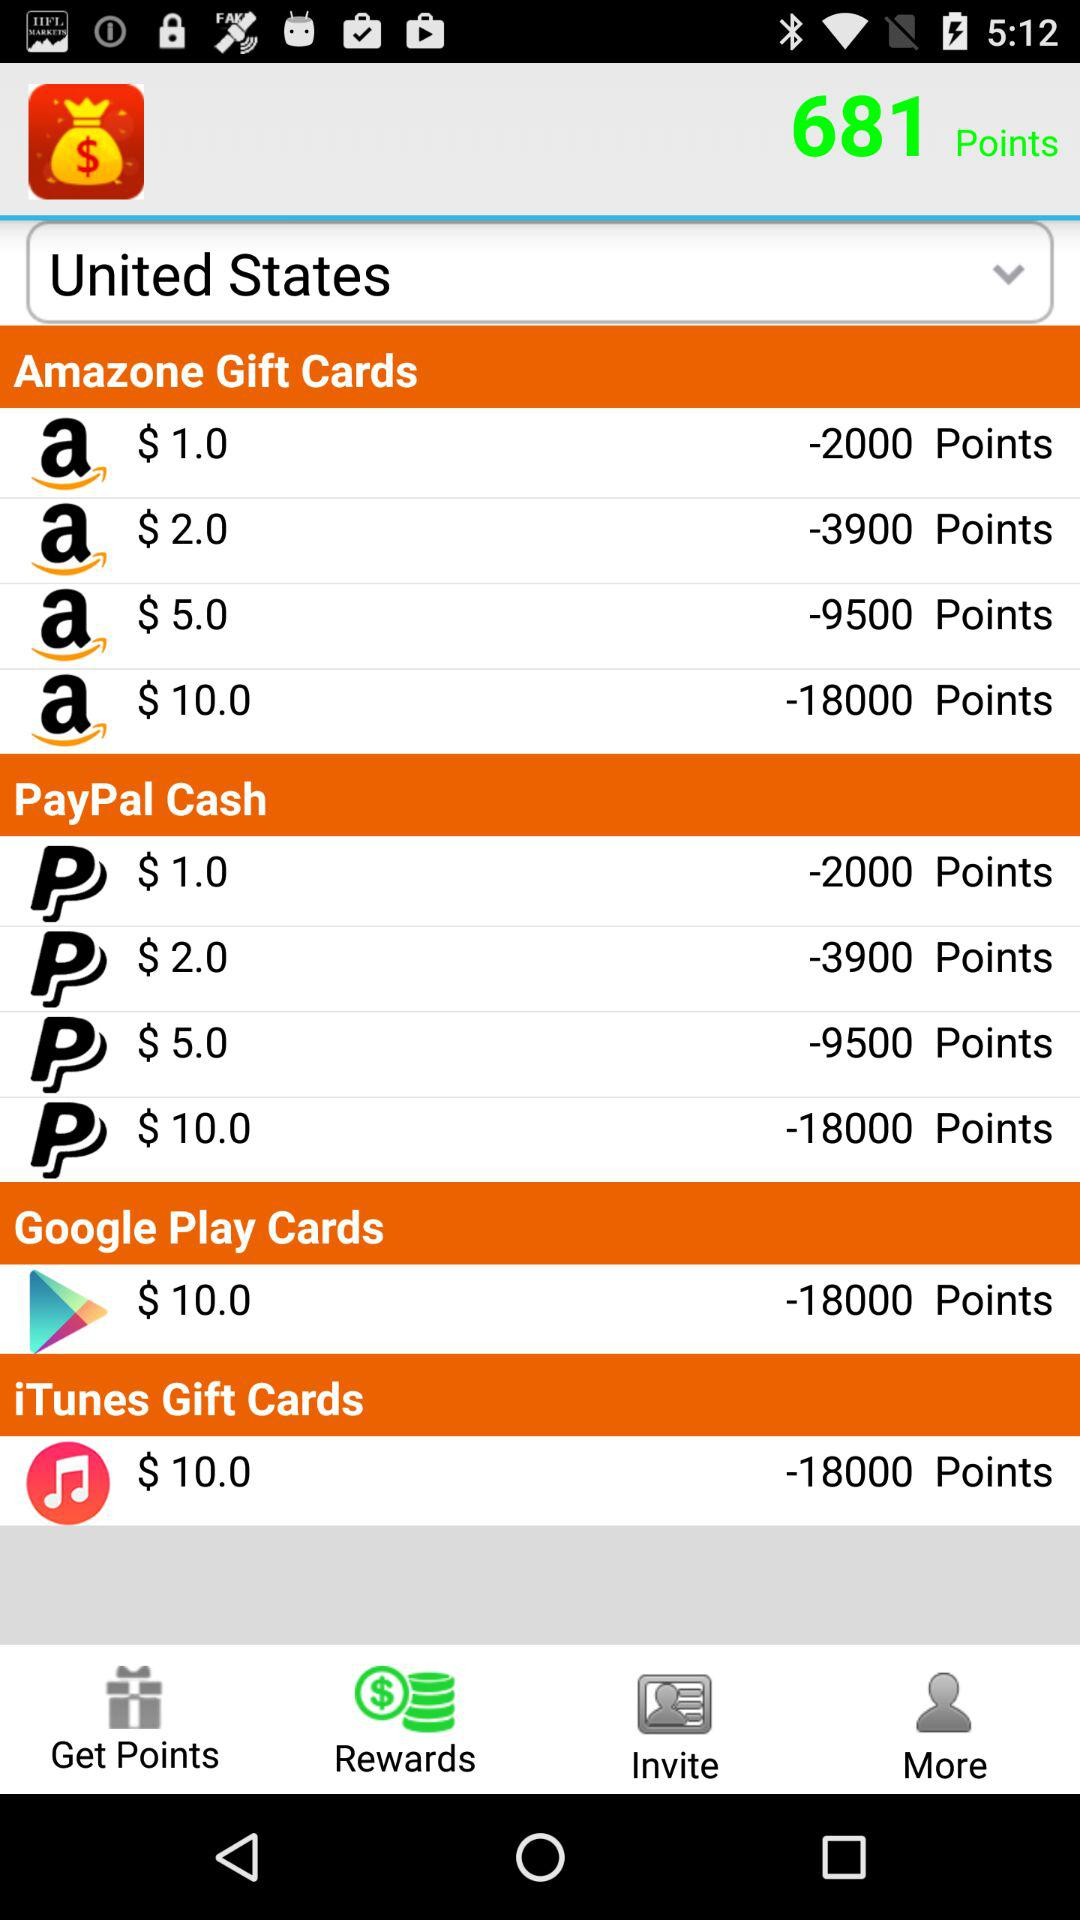Which currency is selected to pay?
When the provided information is insufficient, respond with <no answer>. <no answer> 